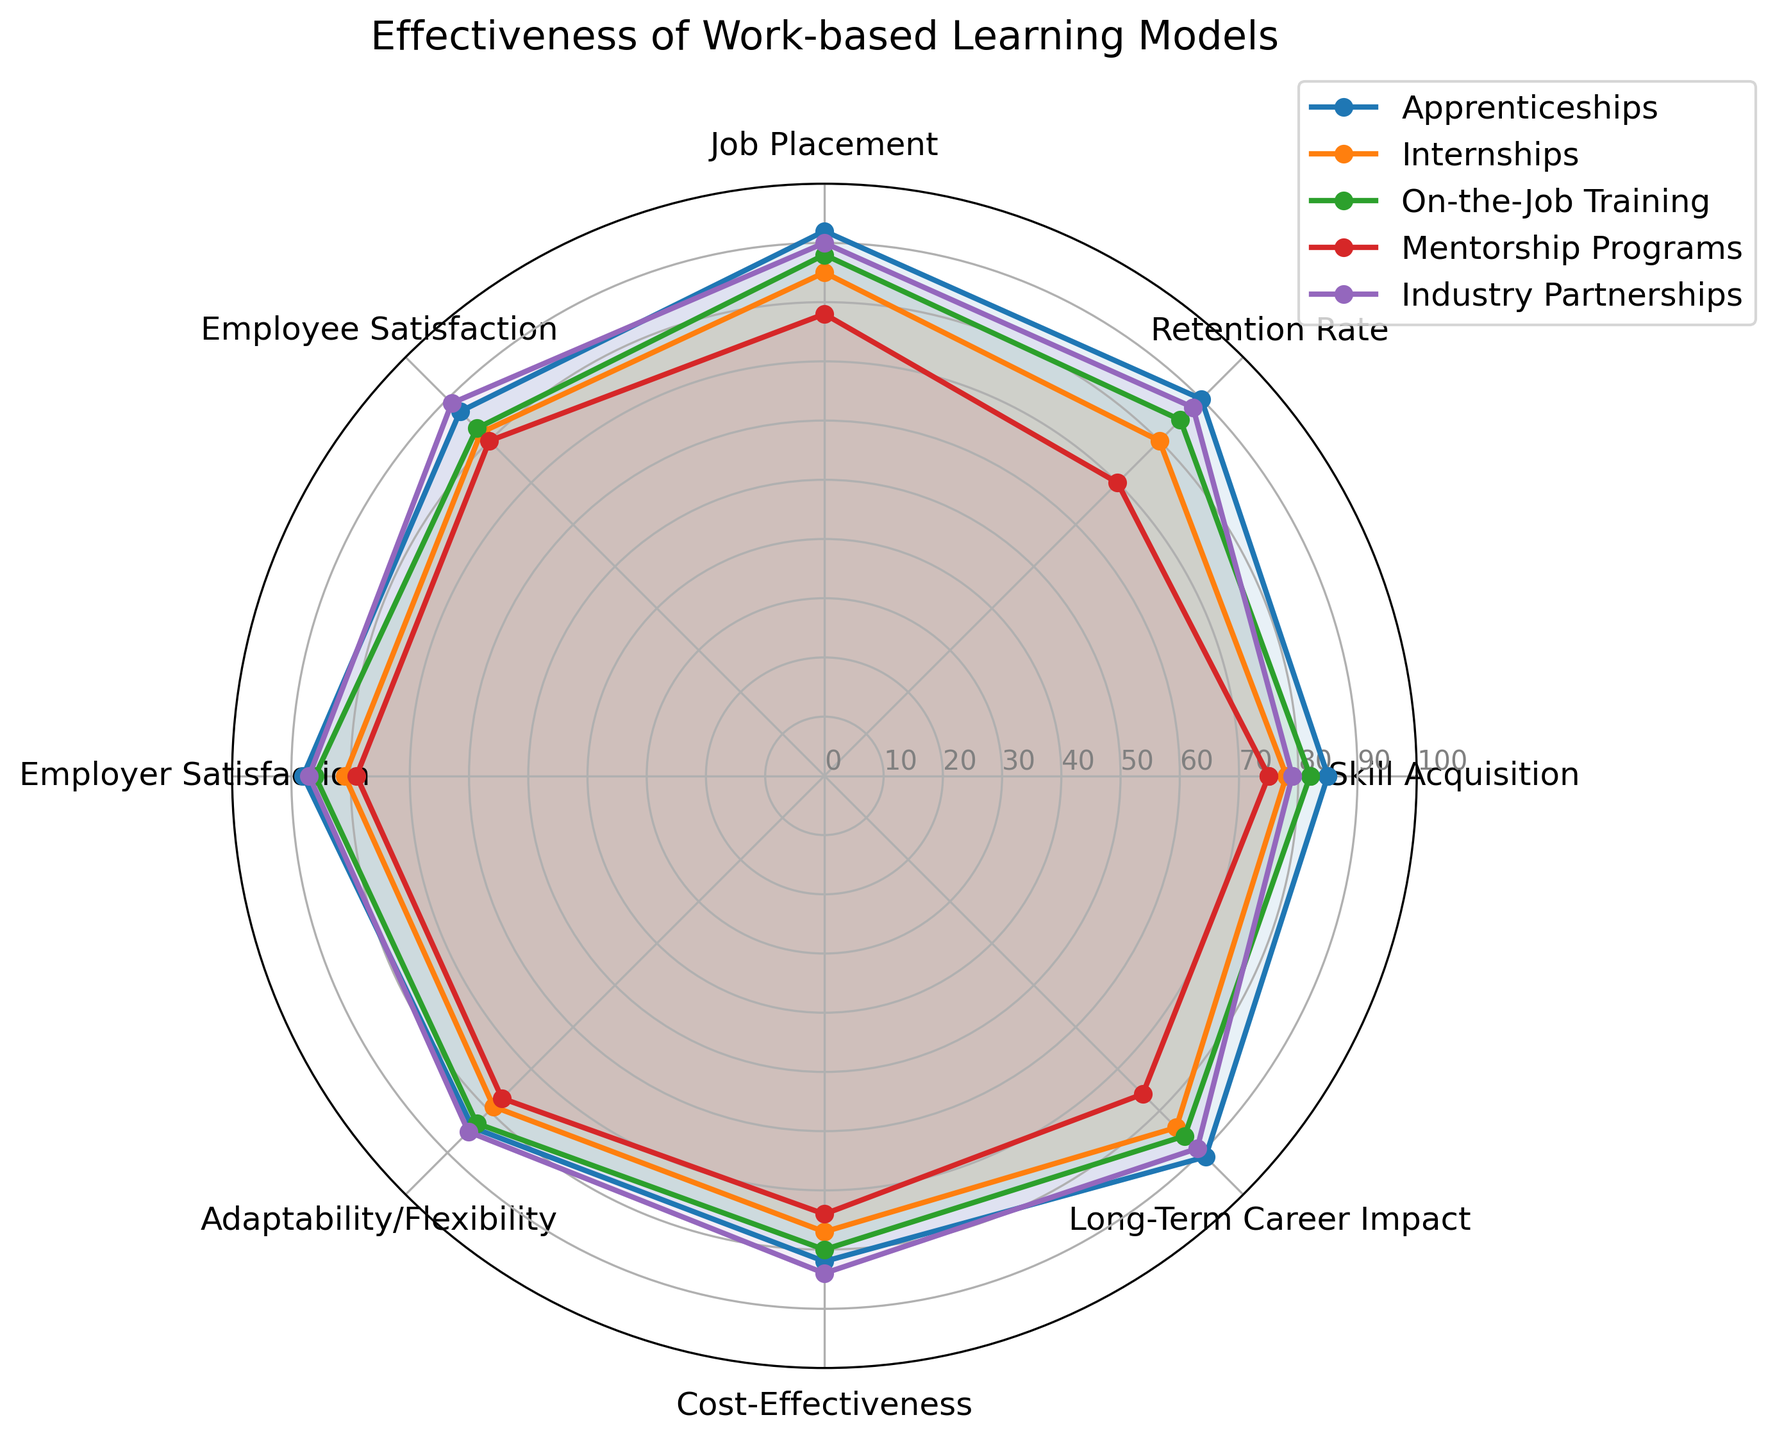Which model has the highest retention rate? By looking at the value for the 'Retention Rate' category in the radar chart, apprenticeships have the highest value at 90.
Answer: Apprenticeships Which models have higher job placement rates than internships? Internships have a job placement rate of 85. Apprenticeships (92), on-the-job training (88), and industry partnerships (90) all have higher rates.
Answer: Apprenticeships, on-the-job training, and industry partnerships How do apprenticeship and internship programs compare in terms of employee satisfaction? By comparing the values in the 'Employee Satisfaction' category, apprenticeships have a satisfaction rate of 87, while internships have a rate of 82.
Answer: Apprenticeships have higher employee satisfaction than internships Which model has the lowest cost-effectiveness? By looking at the 'Cost-Effectiveness' values, mentorship programs have the lowest cost-effectiveness score of 74.
Answer: Mentorship programs What is the average score for adaptability/flexibility across all models? Sum the scores for adaptability/flexibility for all models (84 + 79 + 83 + 77 + 85 = 408) and divide by the number of models (5). The average is 408 / 5 = 81.6.
Answer: 81.6 Among the work-based learning models, which one has the highest long-term career impact? By looking at the 'Long-Term Career Impact' category, apprenticeships and industry partnerships both have the highest value at 91 and 89 respectively.
Answer: Apprenticeships How do mentorship programs and industry partnerships compare in terms of cost-effectiveness and long-term career impact? Mentorship programs have a cost-effectiveness score of 74 and a long-term career impact of 76. Industry partnerships have a cost-effectiveness of 84 and a long-term career impact of 89. Thus, industry partnerships are better in both categories.
Answer: Industry partnerships are better in both categories Which model has the most balanced performance across all categories? By examining the radar chart, apprenticeships have consistently high ratings across all categories compared to the others.
Answer: Apprenticeships What is the difference in employer satisfaction between on-the-job training and mentorship programs? On-the-job training has an employer satisfaction rate of 86, while mentorship programs have a rate of 79. The difference is 86 - 79 = 7.
Answer: 7 Which categories do internships score lower than apprenticeships, and by how much in each? Apprenticeships score higher in all categories compared to internships. Specifically:
- Skill Acquisition: 85 - 78 = 7
- Retention Rate: 90 - 80 = 10
- Job Placement: 92 - 85 = 7
- Employee Satisfaction: 87 - 82 = 5
- Employer Satisfaction: 88 - 81 = 7
- Adaptability/Flexibility: 84 - 79 = 5
- Cost-Effectiveness: 82 - 77 = 5
- Long-Term Career Impact: 91 - 84 = 7
Answer: All categories, with respective differences of 7, 10, 7, 5, 7, 5, 5, 7 